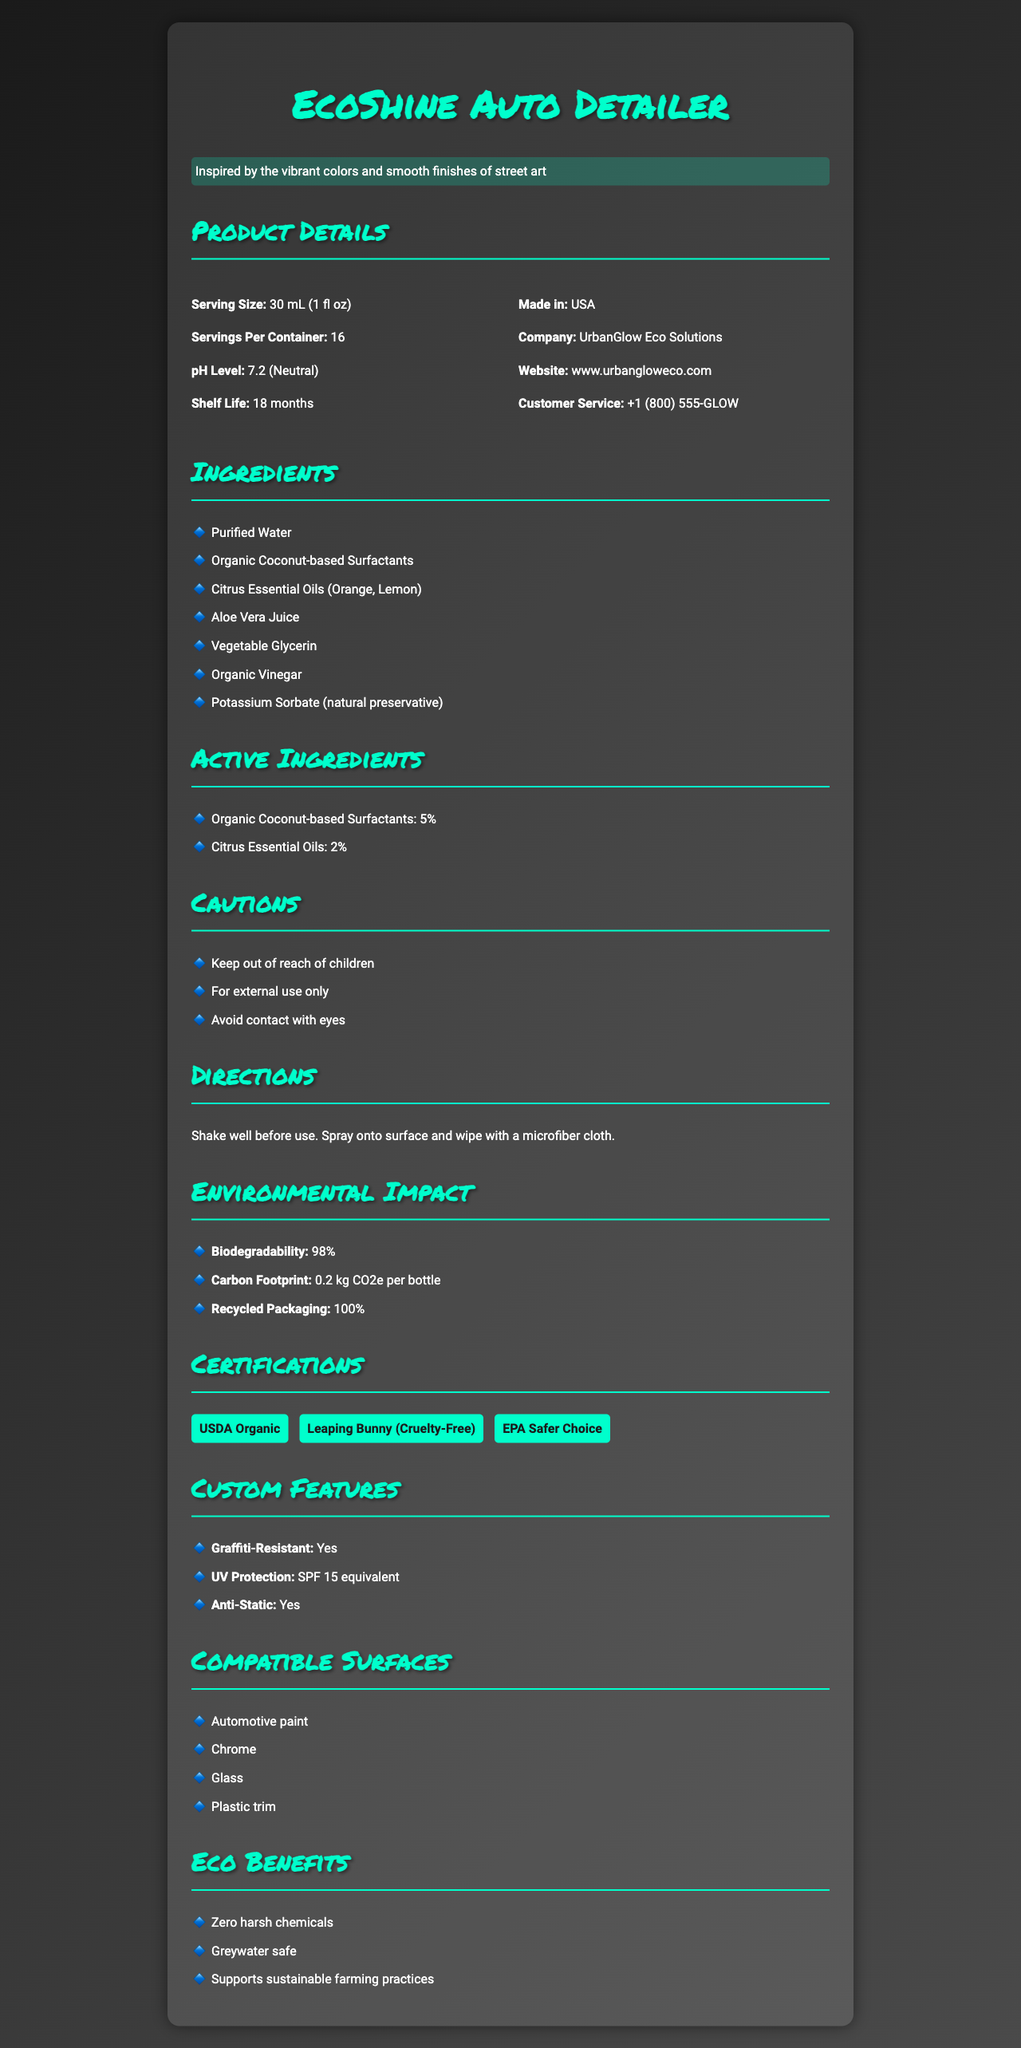what is the serving size of EcoShine Auto Detailer? The document specifies the serving size as 30 mL (1 fl oz) under the Product Details section.
Answer: 30 mL (1 fl oz) how many servings are in one container of EcoShine Auto Detailer? Under the Product Details section, it states that there are 16 servings per container.
Answer: 16 what are the percentages of the active ingredients in the EcoShine Auto Detailer? The Active Ingredients section lists Organic Coconut-based Surfactants at 5% and Citrus Essential Oils at 2%.
Answer: Organic Coconut-based Surfactants: 5%, Citrus Essential Oils: 2% what is the pH level of EcoShine Auto Detailer? The pH level of 7.2 is mentioned under the Product Details section.
Answer: 7.2 (Neutral) what is the shelf life of the EcoShine Auto Detailer? The Product Details section mentions that the shelf life is 18 months.
Answer: 18 months which certifications does EcoShine Auto Detailer have? A. USDA Organic B. Leaping Bunny C. EPA Safer Choice D. All of the above The Certifications section includes USDA Organic, Leaping Bunny, and EPA Safer Choice, indicating all the listed certifications are applicable.
Answer: D. All of the above which of the following surfaces is EcoShine Auto Detailer compatible with? I. Automotive paint II. Wood III. Chrome IV. Glass The Compatible Surfaces section lists Automotive paint, Chrome, Glass, and Plastic trim. Wood is not listed.
Answer: I, III, and IV does EcoShine Auto Detailer have graffiti-resistant properties? The Custom Features section states that the product is graffiti-resistant.
Answer: Yes is EcoShine Auto Detailer safe to use internally? One of the cautions mentioned is "For external use only," implying it is not safe for internal use.
Answer: No what are some of the key environmental benefits of using EcoShine Auto Detailer? The Eco Benefits section outlines these three key environmental benefits.
Answer: Zero harsh chemicals, Greywater safe, Supports sustainable farming practices summarize the main idea of the document. The document provides detailed information about the composition, benefits, usage, and environmental impact of EcoShine Auto Detailer, emphasizing its eco-friendly attributes and organic certifications.
Answer: EcoShine Auto Detailer is an organic, eco-friendly cleaning solution for auto detailing, highlighting its environmentally friendly components, certifications, safety precautions, and usage directions. who is the target market for EcoShine Auto Detailer? The document does not explicitly mention the target market for the product.
Answer: Cannot be determined where is EcoShine Auto Detailer manufactured? The Product Details section lists the country of manufacture as the USA.
Answer: USA what is the carbon footprint per bottle of EcoShine Auto Detailer? The Environmental Impact section specifies the carbon footprint as 0.2 kg CO2e per bottle.
Answer: 0.2 kg CO2e per bottle name one essential oil used in EcoShine Auto Detailer. The Ingredients section lists Citrus Essential Oils, specified as Orange and Lemon.
Answer: Orange 